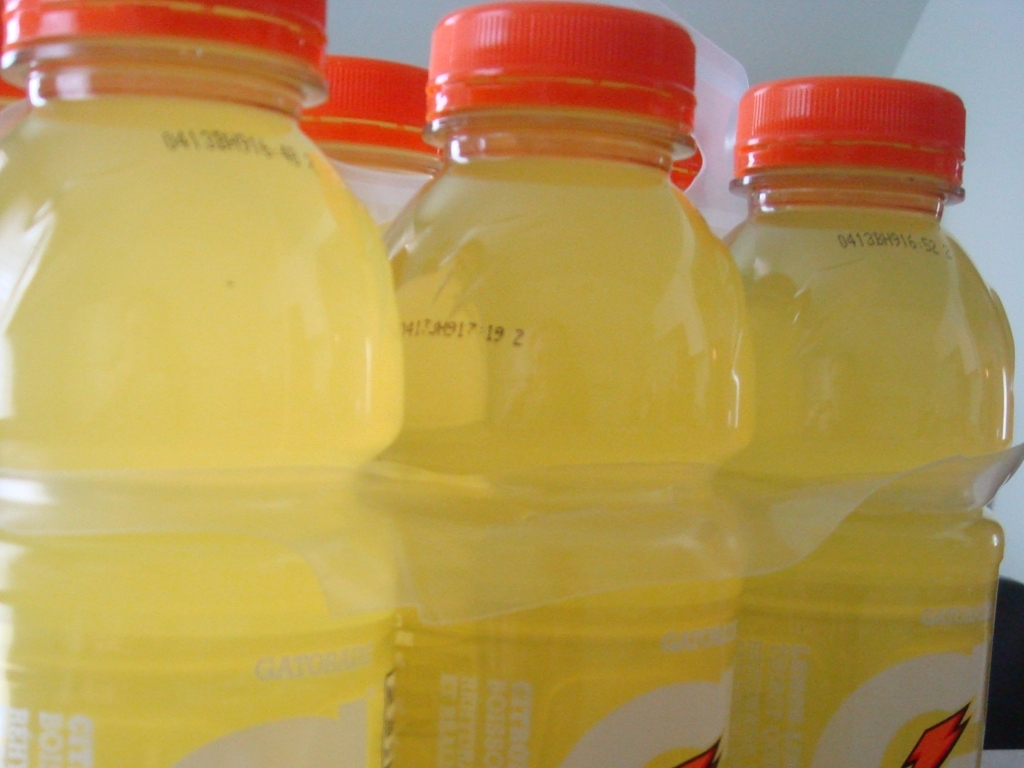Could you describe the composition of this photo? The composition features a close-up perspective on a trio of sports drink bottles aligned in a row. The focal depth places emphasis on the bottles, which are slightly offset from one another, allowing viewers to see the labels and contents clearly. 